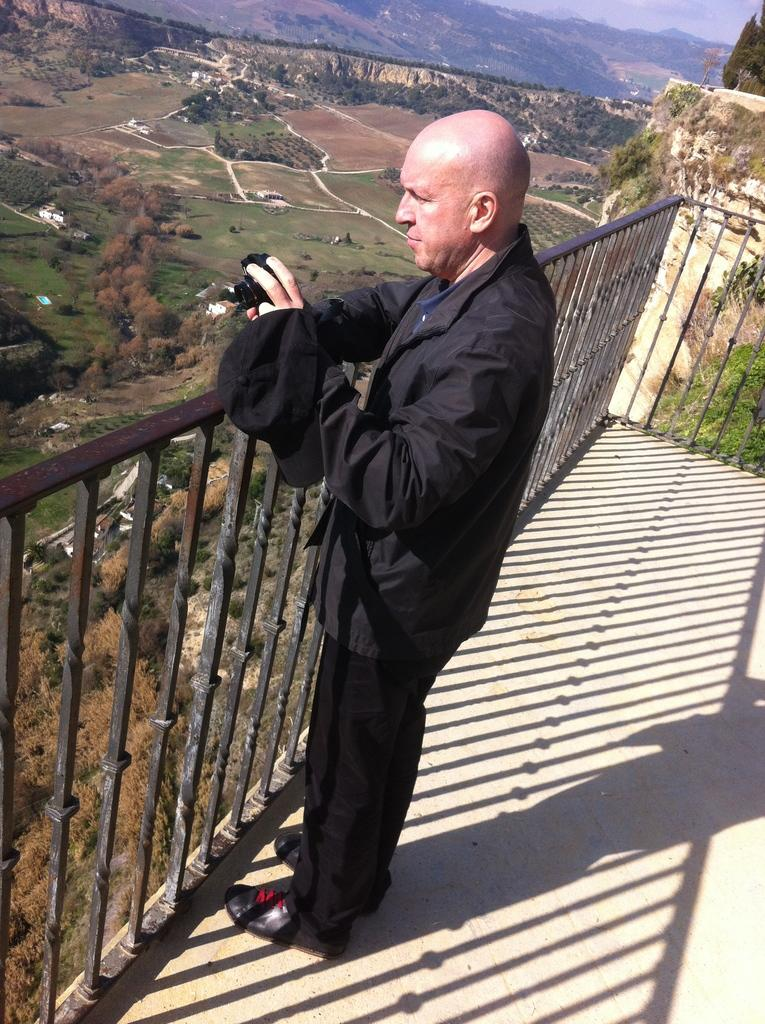What is the main subject of the image? The main subject of the image is a man. What is the man doing in the image? The man is standing and holding a camera. What is the man wearing on his head? The man is wearing a cap. What can be seen in the background of the image? Trees, buildings, and a hill are visible in the background of the image. What might suggest the location from where the image was taken? The image appears to be taken from a balcony. What type of potato is being sold at the market in the image? There is no market or potato present in the image; it features a man standing on a balcony holding a camera. What kind of badge is the man wearing in the image? The man is not wearing a badge in the image; he is wearing a cap. 